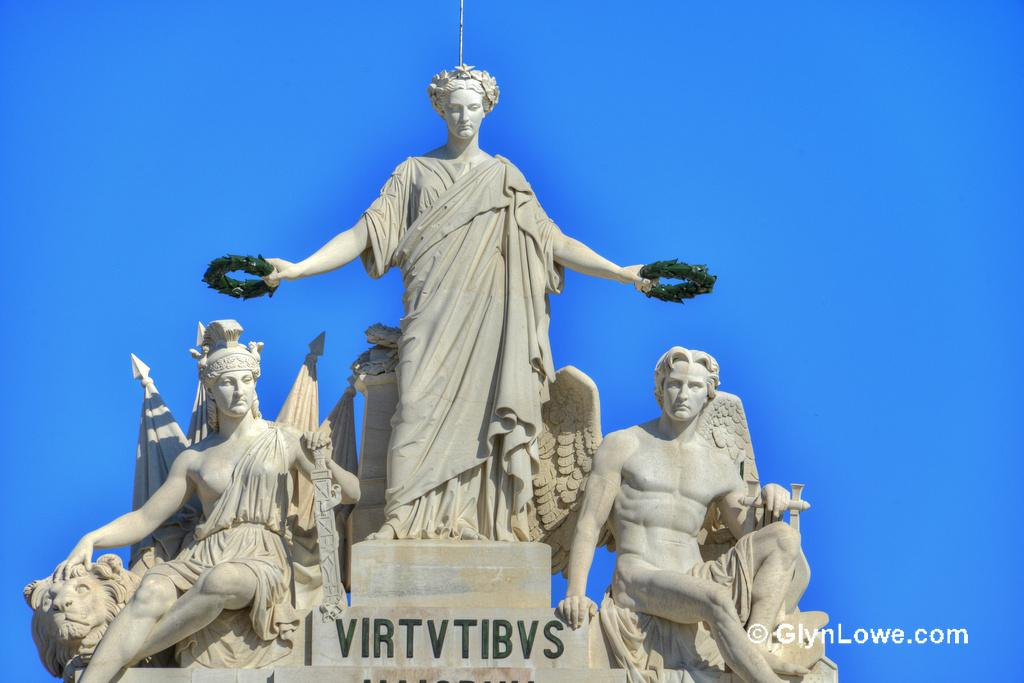What type of objects can be seen in the image? There are statues in the image. Is there any text present in the image? Yes, there is text at the bottom of the image. Can you see any boats in the harbor in the image? There is no harbor or boats present in the image; it features statues and text. What type of hole can be seen in the school depicted in the image? There is no school or hole present in the image; it features statues and text. 